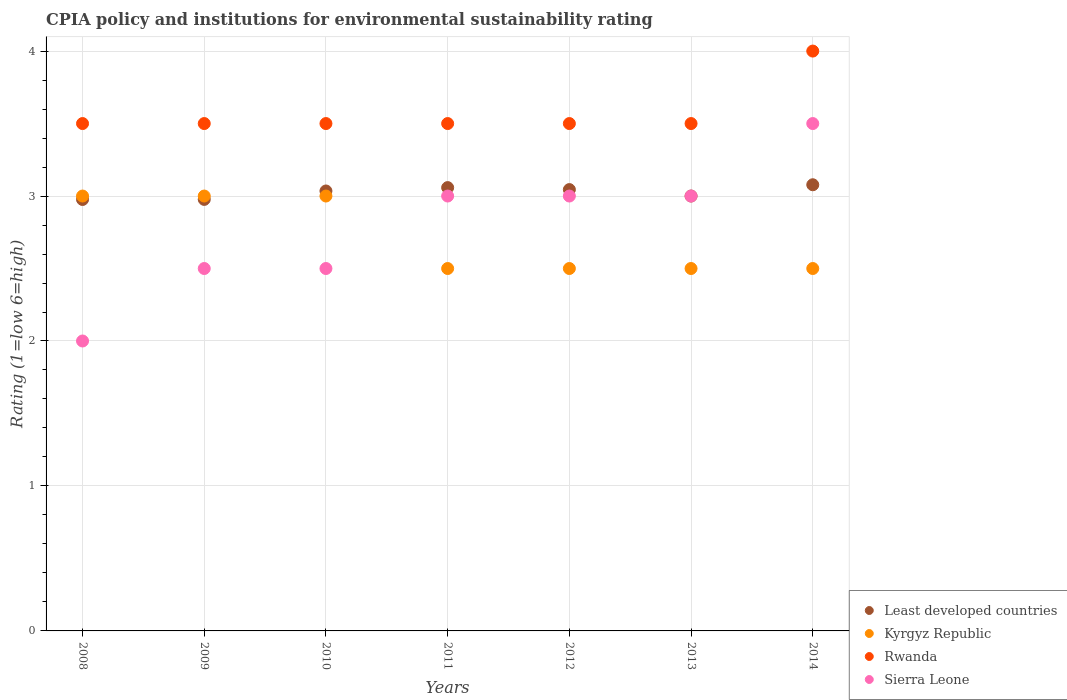How many different coloured dotlines are there?
Give a very brief answer. 4. Is the number of dotlines equal to the number of legend labels?
Your answer should be very brief. Yes. What is the CPIA rating in Sierra Leone in 2013?
Your answer should be compact. 3. Across all years, what is the minimum CPIA rating in Rwanda?
Give a very brief answer. 3.5. In which year was the CPIA rating in Sierra Leone maximum?
Ensure brevity in your answer.  2014. In which year was the CPIA rating in Rwanda minimum?
Make the answer very short. 2008. What is the total CPIA rating in Least developed countries in the graph?
Provide a succinct answer. 21.17. What is the difference between the CPIA rating in Least developed countries in 2008 and that in 2012?
Make the answer very short. -0.07. What is the difference between the CPIA rating in Least developed countries in 2012 and the CPIA rating in Sierra Leone in 2009?
Keep it short and to the point. 0.54. What is the average CPIA rating in Rwanda per year?
Offer a very short reply. 3.57. In the year 2008, what is the difference between the CPIA rating in Kyrgyz Republic and CPIA rating in Sierra Leone?
Provide a short and direct response. 1. What is the ratio of the CPIA rating in Sierra Leone in 2008 to that in 2009?
Your answer should be very brief. 0.8. Is it the case that in every year, the sum of the CPIA rating in Rwanda and CPIA rating in Least developed countries  is greater than the sum of CPIA rating in Kyrgyz Republic and CPIA rating in Sierra Leone?
Your response must be concise. Yes. Is the CPIA rating in Kyrgyz Republic strictly greater than the CPIA rating in Rwanda over the years?
Offer a terse response. No. How many dotlines are there?
Offer a terse response. 4. Are the values on the major ticks of Y-axis written in scientific E-notation?
Offer a terse response. No. Where does the legend appear in the graph?
Offer a terse response. Bottom right. What is the title of the graph?
Your response must be concise. CPIA policy and institutions for environmental sustainability rating. What is the label or title of the Y-axis?
Make the answer very short. Rating (1=low 6=high). What is the Rating (1=low 6=high) in Least developed countries in 2008?
Your answer should be compact. 2.98. What is the Rating (1=low 6=high) in Kyrgyz Republic in 2008?
Your answer should be compact. 3. What is the Rating (1=low 6=high) in Least developed countries in 2009?
Offer a very short reply. 2.98. What is the Rating (1=low 6=high) in Least developed countries in 2010?
Offer a terse response. 3.03. What is the Rating (1=low 6=high) in Kyrgyz Republic in 2010?
Provide a succinct answer. 3. What is the Rating (1=low 6=high) in Rwanda in 2010?
Ensure brevity in your answer.  3.5. What is the Rating (1=low 6=high) of Sierra Leone in 2010?
Ensure brevity in your answer.  2.5. What is the Rating (1=low 6=high) in Least developed countries in 2011?
Make the answer very short. 3.06. What is the Rating (1=low 6=high) of Rwanda in 2011?
Offer a very short reply. 3.5. What is the Rating (1=low 6=high) in Least developed countries in 2012?
Make the answer very short. 3.04. What is the Rating (1=low 6=high) of Least developed countries in 2013?
Ensure brevity in your answer.  3. What is the Rating (1=low 6=high) in Sierra Leone in 2013?
Keep it short and to the point. 3. What is the Rating (1=low 6=high) in Least developed countries in 2014?
Offer a terse response. 3.08. What is the Rating (1=low 6=high) in Rwanda in 2014?
Offer a terse response. 4. What is the Rating (1=low 6=high) of Sierra Leone in 2014?
Make the answer very short. 3.5. Across all years, what is the maximum Rating (1=low 6=high) of Least developed countries?
Provide a short and direct response. 3.08. Across all years, what is the maximum Rating (1=low 6=high) in Kyrgyz Republic?
Your answer should be very brief. 3. Across all years, what is the maximum Rating (1=low 6=high) of Rwanda?
Offer a very short reply. 4. Across all years, what is the minimum Rating (1=low 6=high) of Least developed countries?
Make the answer very short. 2.98. Across all years, what is the minimum Rating (1=low 6=high) of Sierra Leone?
Your answer should be compact. 2. What is the total Rating (1=low 6=high) in Least developed countries in the graph?
Make the answer very short. 21.17. What is the total Rating (1=low 6=high) of Rwanda in the graph?
Offer a very short reply. 25. What is the difference between the Rating (1=low 6=high) of Least developed countries in 2008 and that in 2009?
Offer a terse response. -0. What is the difference between the Rating (1=low 6=high) of Kyrgyz Republic in 2008 and that in 2009?
Your response must be concise. 0. What is the difference between the Rating (1=low 6=high) of Sierra Leone in 2008 and that in 2009?
Give a very brief answer. -0.5. What is the difference between the Rating (1=low 6=high) of Least developed countries in 2008 and that in 2010?
Keep it short and to the point. -0.06. What is the difference between the Rating (1=low 6=high) of Kyrgyz Republic in 2008 and that in 2010?
Give a very brief answer. 0. What is the difference between the Rating (1=low 6=high) in Sierra Leone in 2008 and that in 2010?
Provide a short and direct response. -0.5. What is the difference between the Rating (1=low 6=high) of Least developed countries in 2008 and that in 2011?
Give a very brief answer. -0.08. What is the difference between the Rating (1=low 6=high) in Sierra Leone in 2008 and that in 2011?
Give a very brief answer. -1. What is the difference between the Rating (1=low 6=high) of Least developed countries in 2008 and that in 2012?
Provide a succinct answer. -0.07. What is the difference between the Rating (1=low 6=high) of Kyrgyz Republic in 2008 and that in 2012?
Provide a succinct answer. 0.5. What is the difference between the Rating (1=low 6=high) in Least developed countries in 2008 and that in 2013?
Make the answer very short. -0.02. What is the difference between the Rating (1=low 6=high) in Rwanda in 2008 and that in 2013?
Ensure brevity in your answer.  0. What is the difference between the Rating (1=low 6=high) of Least developed countries in 2008 and that in 2014?
Provide a short and direct response. -0.1. What is the difference between the Rating (1=low 6=high) of Kyrgyz Republic in 2008 and that in 2014?
Give a very brief answer. 0.5. What is the difference between the Rating (1=low 6=high) in Least developed countries in 2009 and that in 2010?
Your answer should be very brief. -0.06. What is the difference between the Rating (1=low 6=high) of Kyrgyz Republic in 2009 and that in 2010?
Ensure brevity in your answer.  0. What is the difference between the Rating (1=low 6=high) in Rwanda in 2009 and that in 2010?
Give a very brief answer. 0. What is the difference between the Rating (1=low 6=high) of Least developed countries in 2009 and that in 2011?
Make the answer very short. -0.08. What is the difference between the Rating (1=low 6=high) of Kyrgyz Republic in 2009 and that in 2011?
Your answer should be very brief. 0.5. What is the difference between the Rating (1=low 6=high) in Least developed countries in 2009 and that in 2012?
Provide a short and direct response. -0.07. What is the difference between the Rating (1=low 6=high) in Sierra Leone in 2009 and that in 2012?
Your response must be concise. -0.5. What is the difference between the Rating (1=low 6=high) of Least developed countries in 2009 and that in 2013?
Ensure brevity in your answer.  -0.02. What is the difference between the Rating (1=low 6=high) of Rwanda in 2009 and that in 2013?
Provide a short and direct response. 0. What is the difference between the Rating (1=low 6=high) in Least developed countries in 2009 and that in 2014?
Offer a very short reply. -0.1. What is the difference between the Rating (1=low 6=high) of Kyrgyz Republic in 2009 and that in 2014?
Give a very brief answer. 0.5. What is the difference between the Rating (1=low 6=high) in Sierra Leone in 2009 and that in 2014?
Your answer should be very brief. -1. What is the difference between the Rating (1=low 6=high) of Least developed countries in 2010 and that in 2011?
Give a very brief answer. -0.02. What is the difference between the Rating (1=low 6=high) of Least developed countries in 2010 and that in 2012?
Your answer should be compact. -0.01. What is the difference between the Rating (1=low 6=high) of Kyrgyz Republic in 2010 and that in 2012?
Keep it short and to the point. 0.5. What is the difference between the Rating (1=low 6=high) in Rwanda in 2010 and that in 2012?
Provide a succinct answer. 0. What is the difference between the Rating (1=low 6=high) of Least developed countries in 2010 and that in 2013?
Your response must be concise. 0.03. What is the difference between the Rating (1=low 6=high) in Kyrgyz Republic in 2010 and that in 2013?
Keep it short and to the point. 0.5. What is the difference between the Rating (1=low 6=high) in Rwanda in 2010 and that in 2013?
Your answer should be very brief. 0. What is the difference between the Rating (1=low 6=high) of Least developed countries in 2010 and that in 2014?
Provide a succinct answer. -0.04. What is the difference between the Rating (1=low 6=high) in Kyrgyz Republic in 2010 and that in 2014?
Ensure brevity in your answer.  0.5. What is the difference between the Rating (1=low 6=high) of Rwanda in 2010 and that in 2014?
Your answer should be very brief. -0.5. What is the difference between the Rating (1=low 6=high) in Sierra Leone in 2010 and that in 2014?
Your answer should be very brief. -1. What is the difference between the Rating (1=low 6=high) in Least developed countries in 2011 and that in 2012?
Provide a short and direct response. 0.01. What is the difference between the Rating (1=low 6=high) in Kyrgyz Republic in 2011 and that in 2012?
Make the answer very short. 0. What is the difference between the Rating (1=low 6=high) in Rwanda in 2011 and that in 2012?
Give a very brief answer. 0. What is the difference between the Rating (1=low 6=high) of Sierra Leone in 2011 and that in 2012?
Give a very brief answer. 0. What is the difference between the Rating (1=low 6=high) in Least developed countries in 2011 and that in 2013?
Your response must be concise. 0.06. What is the difference between the Rating (1=low 6=high) of Kyrgyz Republic in 2011 and that in 2013?
Make the answer very short. 0. What is the difference between the Rating (1=low 6=high) of Sierra Leone in 2011 and that in 2013?
Offer a very short reply. 0. What is the difference between the Rating (1=low 6=high) of Least developed countries in 2011 and that in 2014?
Offer a terse response. -0.02. What is the difference between the Rating (1=low 6=high) of Kyrgyz Republic in 2011 and that in 2014?
Your response must be concise. 0. What is the difference between the Rating (1=low 6=high) in Rwanda in 2011 and that in 2014?
Your answer should be compact. -0.5. What is the difference between the Rating (1=low 6=high) in Sierra Leone in 2011 and that in 2014?
Provide a short and direct response. -0.5. What is the difference between the Rating (1=low 6=high) of Least developed countries in 2012 and that in 2013?
Give a very brief answer. 0.04. What is the difference between the Rating (1=low 6=high) of Kyrgyz Republic in 2012 and that in 2013?
Ensure brevity in your answer.  0. What is the difference between the Rating (1=low 6=high) in Rwanda in 2012 and that in 2013?
Offer a terse response. 0. What is the difference between the Rating (1=low 6=high) in Least developed countries in 2012 and that in 2014?
Your response must be concise. -0.03. What is the difference between the Rating (1=low 6=high) of Least developed countries in 2013 and that in 2014?
Your answer should be compact. -0.08. What is the difference between the Rating (1=low 6=high) in Rwanda in 2013 and that in 2014?
Make the answer very short. -0.5. What is the difference between the Rating (1=low 6=high) in Sierra Leone in 2013 and that in 2014?
Your answer should be compact. -0.5. What is the difference between the Rating (1=low 6=high) in Least developed countries in 2008 and the Rating (1=low 6=high) in Kyrgyz Republic in 2009?
Your answer should be very brief. -0.02. What is the difference between the Rating (1=low 6=high) of Least developed countries in 2008 and the Rating (1=low 6=high) of Rwanda in 2009?
Keep it short and to the point. -0.52. What is the difference between the Rating (1=low 6=high) of Least developed countries in 2008 and the Rating (1=low 6=high) of Sierra Leone in 2009?
Make the answer very short. 0.48. What is the difference between the Rating (1=low 6=high) in Kyrgyz Republic in 2008 and the Rating (1=low 6=high) in Rwanda in 2009?
Keep it short and to the point. -0.5. What is the difference between the Rating (1=low 6=high) in Kyrgyz Republic in 2008 and the Rating (1=low 6=high) in Sierra Leone in 2009?
Offer a very short reply. 0.5. What is the difference between the Rating (1=low 6=high) of Least developed countries in 2008 and the Rating (1=low 6=high) of Kyrgyz Republic in 2010?
Provide a short and direct response. -0.02. What is the difference between the Rating (1=low 6=high) of Least developed countries in 2008 and the Rating (1=low 6=high) of Rwanda in 2010?
Offer a terse response. -0.52. What is the difference between the Rating (1=low 6=high) in Least developed countries in 2008 and the Rating (1=low 6=high) in Sierra Leone in 2010?
Offer a terse response. 0.48. What is the difference between the Rating (1=low 6=high) of Least developed countries in 2008 and the Rating (1=low 6=high) of Kyrgyz Republic in 2011?
Your answer should be compact. 0.48. What is the difference between the Rating (1=low 6=high) in Least developed countries in 2008 and the Rating (1=low 6=high) in Rwanda in 2011?
Your answer should be very brief. -0.52. What is the difference between the Rating (1=low 6=high) of Least developed countries in 2008 and the Rating (1=low 6=high) of Sierra Leone in 2011?
Provide a succinct answer. -0.02. What is the difference between the Rating (1=low 6=high) in Kyrgyz Republic in 2008 and the Rating (1=low 6=high) in Sierra Leone in 2011?
Ensure brevity in your answer.  0. What is the difference between the Rating (1=low 6=high) of Rwanda in 2008 and the Rating (1=low 6=high) of Sierra Leone in 2011?
Offer a terse response. 0.5. What is the difference between the Rating (1=low 6=high) in Least developed countries in 2008 and the Rating (1=low 6=high) in Kyrgyz Republic in 2012?
Keep it short and to the point. 0.48. What is the difference between the Rating (1=low 6=high) of Least developed countries in 2008 and the Rating (1=low 6=high) of Rwanda in 2012?
Ensure brevity in your answer.  -0.52. What is the difference between the Rating (1=low 6=high) of Least developed countries in 2008 and the Rating (1=low 6=high) of Sierra Leone in 2012?
Give a very brief answer. -0.02. What is the difference between the Rating (1=low 6=high) of Kyrgyz Republic in 2008 and the Rating (1=low 6=high) of Sierra Leone in 2012?
Ensure brevity in your answer.  0. What is the difference between the Rating (1=low 6=high) of Rwanda in 2008 and the Rating (1=low 6=high) of Sierra Leone in 2012?
Provide a succinct answer. 0.5. What is the difference between the Rating (1=low 6=high) of Least developed countries in 2008 and the Rating (1=low 6=high) of Kyrgyz Republic in 2013?
Your answer should be very brief. 0.48. What is the difference between the Rating (1=low 6=high) in Least developed countries in 2008 and the Rating (1=low 6=high) in Rwanda in 2013?
Make the answer very short. -0.52. What is the difference between the Rating (1=low 6=high) in Least developed countries in 2008 and the Rating (1=low 6=high) in Sierra Leone in 2013?
Ensure brevity in your answer.  -0.02. What is the difference between the Rating (1=low 6=high) in Kyrgyz Republic in 2008 and the Rating (1=low 6=high) in Rwanda in 2013?
Provide a short and direct response. -0.5. What is the difference between the Rating (1=low 6=high) in Least developed countries in 2008 and the Rating (1=low 6=high) in Kyrgyz Republic in 2014?
Make the answer very short. 0.48. What is the difference between the Rating (1=low 6=high) in Least developed countries in 2008 and the Rating (1=low 6=high) in Rwanda in 2014?
Your answer should be very brief. -1.02. What is the difference between the Rating (1=low 6=high) of Least developed countries in 2008 and the Rating (1=low 6=high) of Sierra Leone in 2014?
Give a very brief answer. -0.52. What is the difference between the Rating (1=low 6=high) in Kyrgyz Republic in 2008 and the Rating (1=low 6=high) in Rwanda in 2014?
Ensure brevity in your answer.  -1. What is the difference between the Rating (1=low 6=high) in Kyrgyz Republic in 2008 and the Rating (1=low 6=high) in Sierra Leone in 2014?
Offer a terse response. -0.5. What is the difference between the Rating (1=low 6=high) of Least developed countries in 2009 and the Rating (1=low 6=high) of Kyrgyz Republic in 2010?
Make the answer very short. -0.02. What is the difference between the Rating (1=low 6=high) in Least developed countries in 2009 and the Rating (1=low 6=high) in Rwanda in 2010?
Give a very brief answer. -0.52. What is the difference between the Rating (1=low 6=high) in Least developed countries in 2009 and the Rating (1=low 6=high) in Sierra Leone in 2010?
Offer a terse response. 0.48. What is the difference between the Rating (1=low 6=high) in Kyrgyz Republic in 2009 and the Rating (1=low 6=high) in Rwanda in 2010?
Make the answer very short. -0.5. What is the difference between the Rating (1=low 6=high) in Kyrgyz Republic in 2009 and the Rating (1=low 6=high) in Sierra Leone in 2010?
Ensure brevity in your answer.  0.5. What is the difference between the Rating (1=low 6=high) in Least developed countries in 2009 and the Rating (1=low 6=high) in Kyrgyz Republic in 2011?
Provide a succinct answer. 0.48. What is the difference between the Rating (1=low 6=high) of Least developed countries in 2009 and the Rating (1=low 6=high) of Rwanda in 2011?
Give a very brief answer. -0.52. What is the difference between the Rating (1=low 6=high) of Least developed countries in 2009 and the Rating (1=low 6=high) of Sierra Leone in 2011?
Provide a succinct answer. -0.02. What is the difference between the Rating (1=low 6=high) of Kyrgyz Republic in 2009 and the Rating (1=low 6=high) of Rwanda in 2011?
Keep it short and to the point. -0.5. What is the difference between the Rating (1=low 6=high) in Least developed countries in 2009 and the Rating (1=low 6=high) in Kyrgyz Republic in 2012?
Your response must be concise. 0.48. What is the difference between the Rating (1=low 6=high) of Least developed countries in 2009 and the Rating (1=low 6=high) of Rwanda in 2012?
Your response must be concise. -0.52. What is the difference between the Rating (1=low 6=high) in Least developed countries in 2009 and the Rating (1=low 6=high) in Sierra Leone in 2012?
Your response must be concise. -0.02. What is the difference between the Rating (1=low 6=high) of Kyrgyz Republic in 2009 and the Rating (1=low 6=high) of Sierra Leone in 2012?
Your response must be concise. 0. What is the difference between the Rating (1=low 6=high) in Least developed countries in 2009 and the Rating (1=low 6=high) in Kyrgyz Republic in 2013?
Give a very brief answer. 0.48. What is the difference between the Rating (1=low 6=high) in Least developed countries in 2009 and the Rating (1=low 6=high) in Rwanda in 2013?
Provide a short and direct response. -0.52. What is the difference between the Rating (1=low 6=high) in Least developed countries in 2009 and the Rating (1=low 6=high) in Sierra Leone in 2013?
Provide a succinct answer. -0.02. What is the difference between the Rating (1=low 6=high) in Kyrgyz Republic in 2009 and the Rating (1=low 6=high) in Rwanda in 2013?
Provide a short and direct response. -0.5. What is the difference between the Rating (1=low 6=high) of Kyrgyz Republic in 2009 and the Rating (1=low 6=high) of Sierra Leone in 2013?
Make the answer very short. 0. What is the difference between the Rating (1=low 6=high) of Rwanda in 2009 and the Rating (1=low 6=high) of Sierra Leone in 2013?
Keep it short and to the point. 0.5. What is the difference between the Rating (1=low 6=high) in Least developed countries in 2009 and the Rating (1=low 6=high) in Kyrgyz Republic in 2014?
Ensure brevity in your answer.  0.48. What is the difference between the Rating (1=low 6=high) in Least developed countries in 2009 and the Rating (1=low 6=high) in Rwanda in 2014?
Make the answer very short. -1.02. What is the difference between the Rating (1=low 6=high) in Least developed countries in 2009 and the Rating (1=low 6=high) in Sierra Leone in 2014?
Ensure brevity in your answer.  -0.52. What is the difference between the Rating (1=low 6=high) of Kyrgyz Republic in 2009 and the Rating (1=low 6=high) of Rwanda in 2014?
Your answer should be very brief. -1. What is the difference between the Rating (1=low 6=high) in Kyrgyz Republic in 2009 and the Rating (1=low 6=high) in Sierra Leone in 2014?
Provide a short and direct response. -0.5. What is the difference between the Rating (1=low 6=high) in Least developed countries in 2010 and the Rating (1=low 6=high) in Kyrgyz Republic in 2011?
Your response must be concise. 0.53. What is the difference between the Rating (1=low 6=high) in Least developed countries in 2010 and the Rating (1=low 6=high) in Rwanda in 2011?
Offer a very short reply. -0.47. What is the difference between the Rating (1=low 6=high) in Least developed countries in 2010 and the Rating (1=low 6=high) in Sierra Leone in 2011?
Provide a short and direct response. 0.03. What is the difference between the Rating (1=low 6=high) in Kyrgyz Republic in 2010 and the Rating (1=low 6=high) in Rwanda in 2011?
Provide a succinct answer. -0.5. What is the difference between the Rating (1=low 6=high) of Kyrgyz Republic in 2010 and the Rating (1=low 6=high) of Sierra Leone in 2011?
Ensure brevity in your answer.  0. What is the difference between the Rating (1=low 6=high) of Least developed countries in 2010 and the Rating (1=low 6=high) of Kyrgyz Republic in 2012?
Offer a terse response. 0.53. What is the difference between the Rating (1=low 6=high) in Least developed countries in 2010 and the Rating (1=low 6=high) in Rwanda in 2012?
Your response must be concise. -0.47. What is the difference between the Rating (1=low 6=high) of Least developed countries in 2010 and the Rating (1=low 6=high) of Sierra Leone in 2012?
Your response must be concise. 0.03. What is the difference between the Rating (1=low 6=high) of Kyrgyz Republic in 2010 and the Rating (1=low 6=high) of Rwanda in 2012?
Your answer should be compact. -0.5. What is the difference between the Rating (1=low 6=high) in Rwanda in 2010 and the Rating (1=low 6=high) in Sierra Leone in 2012?
Provide a succinct answer. 0.5. What is the difference between the Rating (1=low 6=high) of Least developed countries in 2010 and the Rating (1=low 6=high) of Kyrgyz Republic in 2013?
Provide a succinct answer. 0.53. What is the difference between the Rating (1=low 6=high) of Least developed countries in 2010 and the Rating (1=low 6=high) of Rwanda in 2013?
Keep it short and to the point. -0.47. What is the difference between the Rating (1=low 6=high) in Least developed countries in 2010 and the Rating (1=low 6=high) in Sierra Leone in 2013?
Offer a terse response. 0.03. What is the difference between the Rating (1=low 6=high) in Kyrgyz Republic in 2010 and the Rating (1=low 6=high) in Rwanda in 2013?
Your answer should be very brief. -0.5. What is the difference between the Rating (1=low 6=high) in Kyrgyz Republic in 2010 and the Rating (1=low 6=high) in Sierra Leone in 2013?
Keep it short and to the point. 0. What is the difference between the Rating (1=low 6=high) of Least developed countries in 2010 and the Rating (1=low 6=high) of Kyrgyz Republic in 2014?
Your response must be concise. 0.53. What is the difference between the Rating (1=low 6=high) in Least developed countries in 2010 and the Rating (1=low 6=high) in Rwanda in 2014?
Provide a short and direct response. -0.97. What is the difference between the Rating (1=low 6=high) of Least developed countries in 2010 and the Rating (1=low 6=high) of Sierra Leone in 2014?
Give a very brief answer. -0.47. What is the difference between the Rating (1=low 6=high) of Kyrgyz Republic in 2010 and the Rating (1=low 6=high) of Rwanda in 2014?
Your answer should be very brief. -1. What is the difference between the Rating (1=low 6=high) of Rwanda in 2010 and the Rating (1=low 6=high) of Sierra Leone in 2014?
Your answer should be compact. 0. What is the difference between the Rating (1=low 6=high) in Least developed countries in 2011 and the Rating (1=low 6=high) in Kyrgyz Republic in 2012?
Ensure brevity in your answer.  0.56. What is the difference between the Rating (1=low 6=high) in Least developed countries in 2011 and the Rating (1=low 6=high) in Rwanda in 2012?
Ensure brevity in your answer.  -0.44. What is the difference between the Rating (1=low 6=high) of Least developed countries in 2011 and the Rating (1=low 6=high) of Sierra Leone in 2012?
Offer a terse response. 0.06. What is the difference between the Rating (1=low 6=high) in Kyrgyz Republic in 2011 and the Rating (1=low 6=high) in Sierra Leone in 2012?
Your response must be concise. -0.5. What is the difference between the Rating (1=low 6=high) in Least developed countries in 2011 and the Rating (1=low 6=high) in Kyrgyz Republic in 2013?
Offer a terse response. 0.56. What is the difference between the Rating (1=low 6=high) in Least developed countries in 2011 and the Rating (1=low 6=high) in Rwanda in 2013?
Provide a succinct answer. -0.44. What is the difference between the Rating (1=low 6=high) of Least developed countries in 2011 and the Rating (1=low 6=high) of Sierra Leone in 2013?
Offer a very short reply. 0.06. What is the difference between the Rating (1=low 6=high) of Kyrgyz Republic in 2011 and the Rating (1=low 6=high) of Sierra Leone in 2013?
Provide a succinct answer. -0.5. What is the difference between the Rating (1=low 6=high) in Rwanda in 2011 and the Rating (1=low 6=high) in Sierra Leone in 2013?
Make the answer very short. 0.5. What is the difference between the Rating (1=low 6=high) of Least developed countries in 2011 and the Rating (1=low 6=high) of Kyrgyz Republic in 2014?
Offer a terse response. 0.56. What is the difference between the Rating (1=low 6=high) in Least developed countries in 2011 and the Rating (1=low 6=high) in Rwanda in 2014?
Provide a succinct answer. -0.94. What is the difference between the Rating (1=low 6=high) in Least developed countries in 2011 and the Rating (1=low 6=high) in Sierra Leone in 2014?
Your response must be concise. -0.44. What is the difference between the Rating (1=low 6=high) in Kyrgyz Republic in 2011 and the Rating (1=low 6=high) in Sierra Leone in 2014?
Offer a terse response. -1. What is the difference between the Rating (1=low 6=high) in Least developed countries in 2012 and the Rating (1=low 6=high) in Kyrgyz Republic in 2013?
Provide a short and direct response. 0.54. What is the difference between the Rating (1=low 6=high) in Least developed countries in 2012 and the Rating (1=low 6=high) in Rwanda in 2013?
Give a very brief answer. -0.46. What is the difference between the Rating (1=low 6=high) in Least developed countries in 2012 and the Rating (1=low 6=high) in Sierra Leone in 2013?
Your answer should be compact. 0.04. What is the difference between the Rating (1=low 6=high) in Kyrgyz Republic in 2012 and the Rating (1=low 6=high) in Rwanda in 2013?
Give a very brief answer. -1. What is the difference between the Rating (1=low 6=high) of Least developed countries in 2012 and the Rating (1=low 6=high) of Kyrgyz Republic in 2014?
Your answer should be compact. 0.54. What is the difference between the Rating (1=low 6=high) of Least developed countries in 2012 and the Rating (1=low 6=high) of Rwanda in 2014?
Provide a succinct answer. -0.96. What is the difference between the Rating (1=low 6=high) of Least developed countries in 2012 and the Rating (1=low 6=high) of Sierra Leone in 2014?
Ensure brevity in your answer.  -0.46. What is the difference between the Rating (1=low 6=high) in Kyrgyz Republic in 2012 and the Rating (1=low 6=high) in Rwanda in 2014?
Give a very brief answer. -1.5. What is the difference between the Rating (1=low 6=high) of Kyrgyz Republic in 2012 and the Rating (1=low 6=high) of Sierra Leone in 2014?
Your response must be concise. -1. What is the difference between the Rating (1=low 6=high) in Least developed countries in 2013 and the Rating (1=low 6=high) in Kyrgyz Republic in 2014?
Your response must be concise. 0.5. What is the difference between the Rating (1=low 6=high) of Kyrgyz Republic in 2013 and the Rating (1=low 6=high) of Sierra Leone in 2014?
Your answer should be very brief. -1. What is the average Rating (1=low 6=high) in Least developed countries per year?
Give a very brief answer. 3.02. What is the average Rating (1=low 6=high) in Kyrgyz Republic per year?
Make the answer very short. 2.71. What is the average Rating (1=low 6=high) of Rwanda per year?
Offer a very short reply. 3.57. What is the average Rating (1=low 6=high) in Sierra Leone per year?
Offer a terse response. 2.79. In the year 2008, what is the difference between the Rating (1=low 6=high) of Least developed countries and Rating (1=low 6=high) of Kyrgyz Republic?
Offer a terse response. -0.02. In the year 2008, what is the difference between the Rating (1=low 6=high) of Least developed countries and Rating (1=low 6=high) of Rwanda?
Offer a very short reply. -0.52. In the year 2008, what is the difference between the Rating (1=low 6=high) of Least developed countries and Rating (1=low 6=high) of Sierra Leone?
Keep it short and to the point. 0.98. In the year 2008, what is the difference between the Rating (1=low 6=high) of Kyrgyz Republic and Rating (1=low 6=high) of Rwanda?
Offer a very short reply. -0.5. In the year 2008, what is the difference between the Rating (1=low 6=high) of Kyrgyz Republic and Rating (1=low 6=high) of Sierra Leone?
Offer a very short reply. 1. In the year 2009, what is the difference between the Rating (1=low 6=high) of Least developed countries and Rating (1=low 6=high) of Kyrgyz Republic?
Give a very brief answer. -0.02. In the year 2009, what is the difference between the Rating (1=low 6=high) in Least developed countries and Rating (1=low 6=high) in Rwanda?
Your answer should be compact. -0.52. In the year 2009, what is the difference between the Rating (1=low 6=high) in Least developed countries and Rating (1=low 6=high) in Sierra Leone?
Keep it short and to the point. 0.48. In the year 2009, what is the difference between the Rating (1=low 6=high) in Kyrgyz Republic and Rating (1=low 6=high) in Rwanda?
Offer a very short reply. -0.5. In the year 2009, what is the difference between the Rating (1=low 6=high) of Kyrgyz Republic and Rating (1=low 6=high) of Sierra Leone?
Your answer should be very brief. 0.5. In the year 2009, what is the difference between the Rating (1=low 6=high) in Rwanda and Rating (1=low 6=high) in Sierra Leone?
Your answer should be compact. 1. In the year 2010, what is the difference between the Rating (1=low 6=high) of Least developed countries and Rating (1=low 6=high) of Kyrgyz Republic?
Provide a succinct answer. 0.03. In the year 2010, what is the difference between the Rating (1=low 6=high) of Least developed countries and Rating (1=low 6=high) of Rwanda?
Your answer should be very brief. -0.47. In the year 2010, what is the difference between the Rating (1=low 6=high) in Least developed countries and Rating (1=low 6=high) in Sierra Leone?
Provide a succinct answer. 0.53. In the year 2010, what is the difference between the Rating (1=low 6=high) of Kyrgyz Republic and Rating (1=low 6=high) of Sierra Leone?
Provide a succinct answer. 0.5. In the year 2011, what is the difference between the Rating (1=low 6=high) of Least developed countries and Rating (1=low 6=high) of Kyrgyz Republic?
Offer a very short reply. 0.56. In the year 2011, what is the difference between the Rating (1=low 6=high) in Least developed countries and Rating (1=low 6=high) in Rwanda?
Provide a succinct answer. -0.44. In the year 2011, what is the difference between the Rating (1=low 6=high) in Least developed countries and Rating (1=low 6=high) in Sierra Leone?
Keep it short and to the point. 0.06. In the year 2011, what is the difference between the Rating (1=low 6=high) in Kyrgyz Republic and Rating (1=low 6=high) in Rwanda?
Keep it short and to the point. -1. In the year 2011, what is the difference between the Rating (1=low 6=high) of Kyrgyz Republic and Rating (1=low 6=high) of Sierra Leone?
Give a very brief answer. -0.5. In the year 2011, what is the difference between the Rating (1=low 6=high) of Rwanda and Rating (1=low 6=high) of Sierra Leone?
Keep it short and to the point. 0.5. In the year 2012, what is the difference between the Rating (1=low 6=high) in Least developed countries and Rating (1=low 6=high) in Kyrgyz Republic?
Offer a terse response. 0.54. In the year 2012, what is the difference between the Rating (1=low 6=high) in Least developed countries and Rating (1=low 6=high) in Rwanda?
Offer a very short reply. -0.46. In the year 2012, what is the difference between the Rating (1=low 6=high) of Least developed countries and Rating (1=low 6=high) of Sierra Leone?
Your answer should be very brief. 0.04. In the year 2012, what is the difference between the Rating (1=low 6=high) in Kyrgyz Republic and Rating (1=low 6=high) in Rwanda?
Ensure brevity in your answer.  -1. In the year 2012, what is the difference between the Rating (1=low 6=high) in Kyrgyz Republic and Rating (1=low 6=high) in Sierra Leone?
Provide a succinct answer. -0.5. In the year 2012, what is the difference between the Rating (1=low 6=high) in Rwanda and Rating (1=low 6=high) in Sierra Leone?
Keep it short and to the point. 0.5. In the year 2013, what is the difference between the Rating (1=low 6=high) in Least developed countries and Rating (1=low 6=high) in Rwanda?
Your response must be concise. -0.5. In the year 2013, what is the difference between the Rating (1=low 6=high) in Least developed countries and Rating (1=low 6=high) in Sierra Leone?
Make the answer very short. 0. In the year 2013, what is the difference between the Rating (1=low 6=high) in Kyrgyz Republic and Rating (1=low 6=high) in Sierra Leone?
Ensure brevity in your answer.  -0.5. In the year 2013, what is the difference between the Rating (1=low 6=high) in Rwanda and Rating (1=low 6=high) in Sierra Leone?
Give a very brief answer. 0.5. In the year 2014, what is the difference between the Rating (1=low 6=high) in Least developed countries and Rating (1=low 6=high) in Kyrgyz Republic?
Offer a very short reply. 0.58. In the year 2014, what is the difference between the Rating (1=low 6=high) in Least developed countries and Rating (1=low 6=high) in Rwanda?
Your answer should be very brief. -0.92. In the year 2014, what is the difference between the Rating (1=low 6=high) in Least developed countries and Rating (1=low 6=high) in Sierra Leone?
Keep it short and to the point. -0.42. In the year 2014, what is the difference between the Rating (1=low 6=high) of Kyrgyz Republic and Rating (1=low 6=high) of Rwanda?
Offer a very short reply. -1.5. What is the ratio of the Rating (1=low 6=high) of Least developed countries in 2008 to that in 2009?
Ensure brevity in your answer.  1. What is the ratio of the Rating (1=low 6=high) of Kyrgyz Republic in 2008 to that in 2009?
Provide a short and direct response. 1. What is the ratio of the Rating (1=low 6=high) in Rwanda in 2008 to that in 2009?
Provide a succinct answer. 1. What is the ratio of the Rating (1=low 6=high) of Least developed countries in 2008 to that in 2010?
Offer a very short reply. 0.98. What is the ratio of the Rating (1=low 6=high) of Kyrgyz Republic in 2008 to that in 2010?
Provide a succinct answer. 1. What is the ratio of the Rating (1=low 6=high) in Rwanda in 2008 to that in 2010?
Provide a succinct answer. 1. What is the ratio of the Rating (1=low 6=high) in Least developed countries in 2008 to that in 2011?
Ensure brevity in your answer.  0.97. What is the ratio of the Rating (1=low 6=high) of Rwanda in 2008 to that in 2011?
Provide a short and direct response. 1. What is the ratio of the Rating (1=low 6=high) in Least developed countries in 2008 to that in 2012?
Give a very brief answer. 0.98. What is the ratio of the Rating (1=low 6=high) of Kyrgyz Republic in 2008 to that in 2012?
Provide a succinct answer. 1.2. What is the ratio of the Rating (1=low 6=high) in Rwanda in 2008 to that in 2012?
Offer a very short reply. 1. What is the ratio of the Rating (1=low 6=high) in Kyrgyz Republic in 2008 to that in 2013?
Your answer should be very brief. 1.2. What is the ratio of the Rating (1=low 6=high) in Rwanda in 2008 to that in 2013?
Provide a succinct answer. 1. What is the ratio of the Rating (1=low 6=high) of Least developed countries in 2009 to that in 2010?
Your response must be concise. 0.98. What is the ratio of the Rating (1=low 6=high) in Sierra Leone in 2009 to that in 2010?
Make the answer very short. 1. What is the ratio of the Rating (1=low 6=high) in Least developed countries in 2009 to that in 2011?
Offer a terse response. 0.97. What is the ratio of the Rating (1=low 6=high) of Sierra Leone in 2009 to that in 2011?
Keep it short and to the point. 0.83. What is the ratio of the Rating (1=low 6=high) in Least developed countries in 2009 to that in 2012?
Offer a terse response. 0.98. What is the ratio of the Rating (1=low 6=high) of Kyrgyz Republic in 2009 to that in 2012?
Offer a very short reply. 1.2. What is the ratio of the Rating (1=low 6=high) in Sierra Leone in 2009 to that in 2012?
Provide a succinct answer. 0.83. What is the ratio of the Rating (1=low 6=high) in Kyrgyz Republic in 2009 to that in 2013?
Give a very brief answer. 1.2. What is the ratio of the Rating (1=low 6=high) of Least developed countries in 2009 to that in 2014?
Offer a very short reply. 0.97. What is the ratio of the Rating (1=low 6=high) of Rwanda in 2009 to that in 2014?
Ensure brevity in your answer.  0.88. What is the ratio of the Rating (1=low 6=high) in Least developed countries in 2010 to that in 2011?
Provide a short and direct response. 0.99. What is the ratio of the Rating (1=low 6=high) of Kyrgyz Republic in 2010 to that in 2011?
Provide a succinct answer. 1.2. What is the ratio of the Rating (1=low 6=high) in Rwanda in 2010 to that in 2011?
Ensure brevity in your answer.  1. What is the ratio of the Rating (1=low 6=high) in Sierra Leone in 2010 to that in 2011?
Keep it short and to the point. 0.83. What is the ratio of the Rating (1=low 6=high) in Sierra Leone in 2010 to that in 2012?
Your answer should be compact. 0.83. What is the ratio of the Rating (1=low 6=high) of Least developed countries in 2010 to that in 2013?
Your answer should be very brief. 1.01. What is the ratio of the Rating (1=low 6=high) of Sierra Leone in 2010 to that in 2013?
Provide a succinct answer. 0.83. What is the ratio of the Rating (1=low 6=high) in Least developed countries in 2010 to that in 2014?
Keep it short and to the point. 0.99. What is the ratio of the Rating (1=low 6=high) in Sierra Leone in 2010 to that in 2014?
Your response must be concise. 0.71. What is the ratio of the Rating (1=low 6=high) of Kyrgyz Republic in 2011 to that in 2012?
Provide a short and direct response. 1. What is the ratio of the Rating (1=low 6=high) of Rwanda in 2011 to that in 2012?
Provide a succinct answer. 1. What is the ratio of the Rating (1=low 6=high) in Sierra Leone in 2011 to that in 2012?
Your answer should be very brief. 1. What is the ratio of the Rating (1=low 6=high) in Least developed countries in 2011 to that in 2013?
Ensure brevity in your answer.  1.02. What is the ratio of the Rating (1=low 6=high) in Rwanda in 2011 to that in 2014?
Provide a succinct answer. 0.88. What is the ratio of the Rating (1=low 6=high) of Sierra Leone in 2011 to that in 2014?
Offer a terse response. 0.86. What is the ratio of the Rating (1=low 6=high) in Least developed countries in 2012 to that in 2013?
Give a very brief answer. 1.01. What is the ratio of the Rating (1=low 6=high) in Kyrgyz Republic in 2012 to that in 2013?
Your answer should be very brief. 1. What is the ratio of the Rating (1=low 6=high) of Rwanda in 2012 to that in 2013?
Give a very brief answer. 1. What is the ratio of the Rating (1=low 6=high) in Rwanda in 2012 to that in 2014?
Your answer should be very brief. 0.88. What is the ratio of the Rating (1=low 6=high) in Least developed countries in 2013 to that in 2014?
Offer a very short reply. 0.97. What is the ratio of the Rating (1=low 6=high) of Sierra Leone in 2013 to that in 2014?
Offer a terse response. 0.86. What is the difference between the highest and the second highest Rating (1=low 6=high) of Least developed countries?
Offer a very short reply. 0.02. What is the difference between the highest and the second highest Rating (1=low 6=high) of Kyrgyz Republic?
Make the answer very short. 0. What is the difference between the highest and the second highest Rating (1=low 6=high) in Sierra Leone?
Provide a succinct answer. 0.5. What is the difference between the highest and the lowest Rating (1=low 6=high) in Least developed countries?
Ensure brevity in your answer.  0.1. What is the difference between the highest and the lowest Rating (1=low 6=high) in Kyrgyz Republic?
Provide a short and direct response. 0.5. 